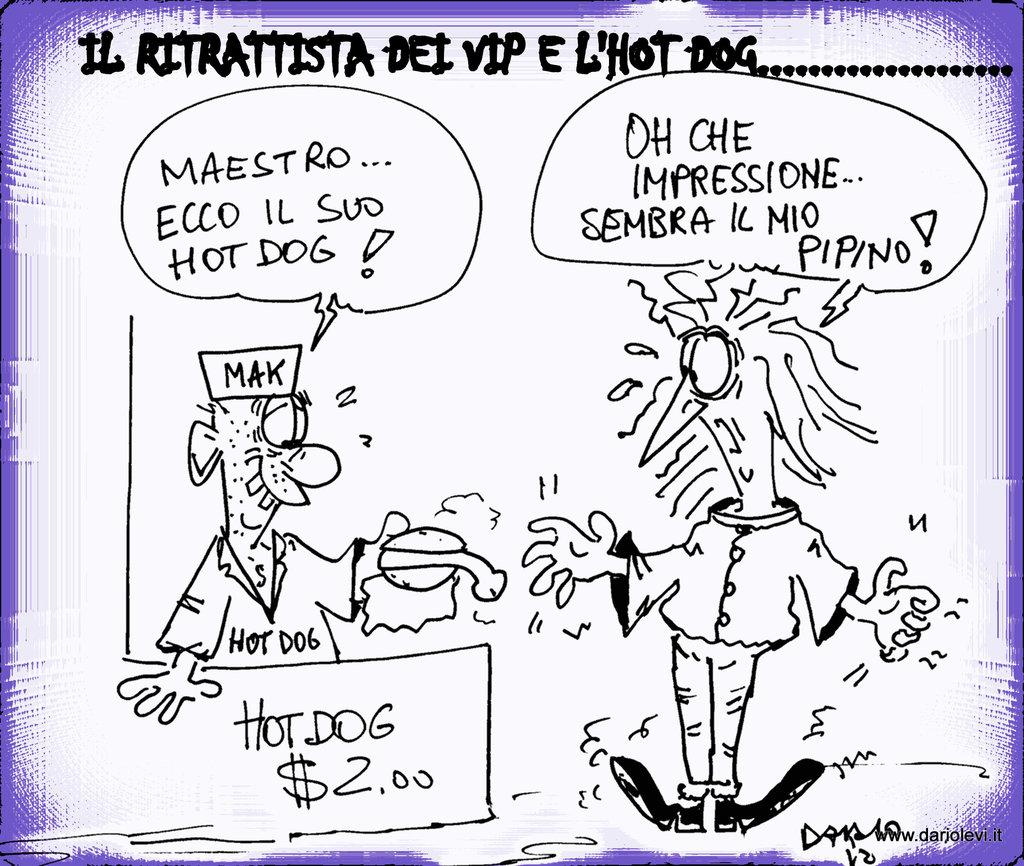What can be seen on the image besides the drawing images? There are texts written on the image. What type of images are depicted on the image? The images on the image are drawing images. What type of disgusting flavor can be tasted in the image? There is no flavor present in the image, as it only contains texts and drawing images. What type of deathly event is depicted in the image? There is no depiction of a deathly event in the image; it only contains texts and drawing images. 